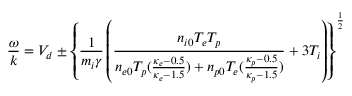<formula> <loc_0><loc_0><loc_500><loc_500>\frac { \omega } { k } = V _ { d } \pm \left \{ \frac { 1 } { m _ { i } \gamma } \left ( \frac { n _ { i 0 } T _ { e } T _ { p } } { n _ { e 0 } T _ { p } ( \frac { \kappa _ { e } - 0 . 5 } { \kappa _ { e } - 1 . 5 } ) + n _ { p 0 } T _ { e } ( \frac { \kappa _ { p } - 0 . 5 } { \kappa _ { p } - 1 . 5 } ) } + 3 T _ { i } \right ) \right \} ^ { \frac { 1 } { 2 } }</formula> 